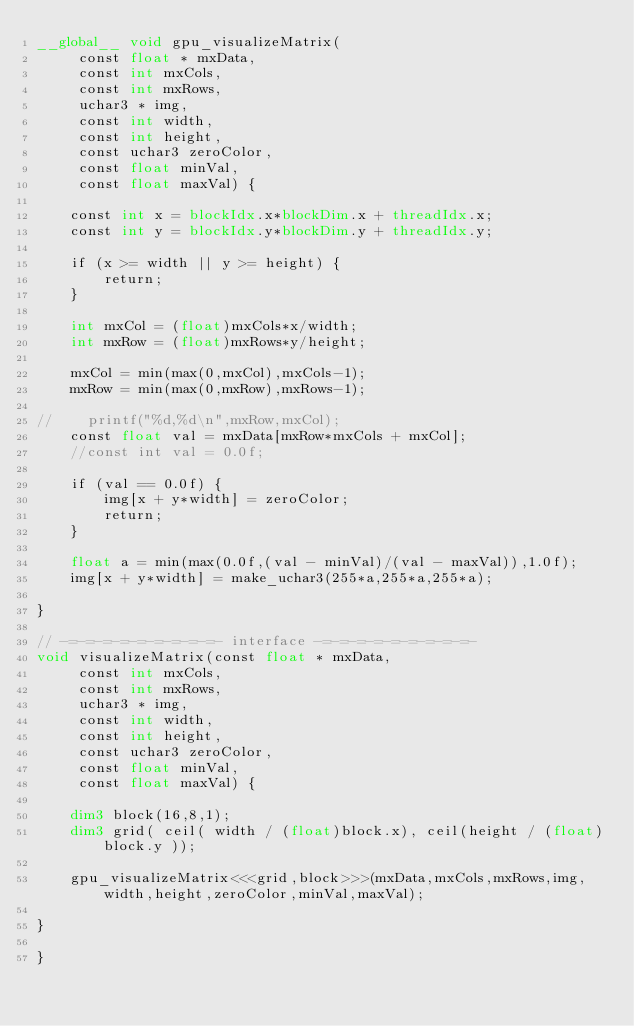Convert code to text. <code><loc_0><loc_0><loc_500><loc_500><_Cuda_>__global__ void gpu_visualizeMatrix(
     const float * mxData,
     const int mxCols,
     const int mxRows,
     uchar3 * img,
     const int width,
     const int height,
     const uchar3 zeroColor,
     const float minVal,
     const float maxVal) {

    const int x = blockIdx.x*blockDim.x + threadIdx.x;
    const int y = blockIdx.y*blockDim.y + threadIdx.y;

    if (x >= width || y >= height) {
        return;
    }

    int mxCol = (float)mxCols*x/width;
    int mxRow = (float)mxRows*y/height;

    mxCol = min(max(0,mxCol),mxCols-1);
    mxRow = min(max(0,mxRow),mxRows-1);

//    printf("%d,%d\n",mxRow,mxCol);
    const float val = mxData[mxRow*mxCols + mxCol];
    //const int val = 0.0f;

    if (val == 0.0f) {
        img[x + y*width] = zeroColor;
        return;
    }

    float a = min(max(0.0f,(val - minVal)/(val - maxVal)),1.0f);
    img[x + y*width] = make_uchar3(255*a,255*a,255*a);

}

// -=-=-=-=-=-=-=-=-=- interface -=-=-=-=-=-=-=-=-=-
void visualizeMatrix(const float * mxData,
     const int mxCols,
     const int mxRows,
     uchar3 * img,
     const int width,
     const int height,
     const uchar3 zeroColor,
     const float minVal,
     const float maxVal) {

    dim3 block(16,8,1);
    dim3 grid( ceil( width / (float)block.x), ceil(height / (float)block.y ));

    gpu_visualizeMatrix<<<grid,block>>>(mxData,mxCols,mxRows,img,width,height,zeroColor,minVal,maxVal);

}

}
</code> 